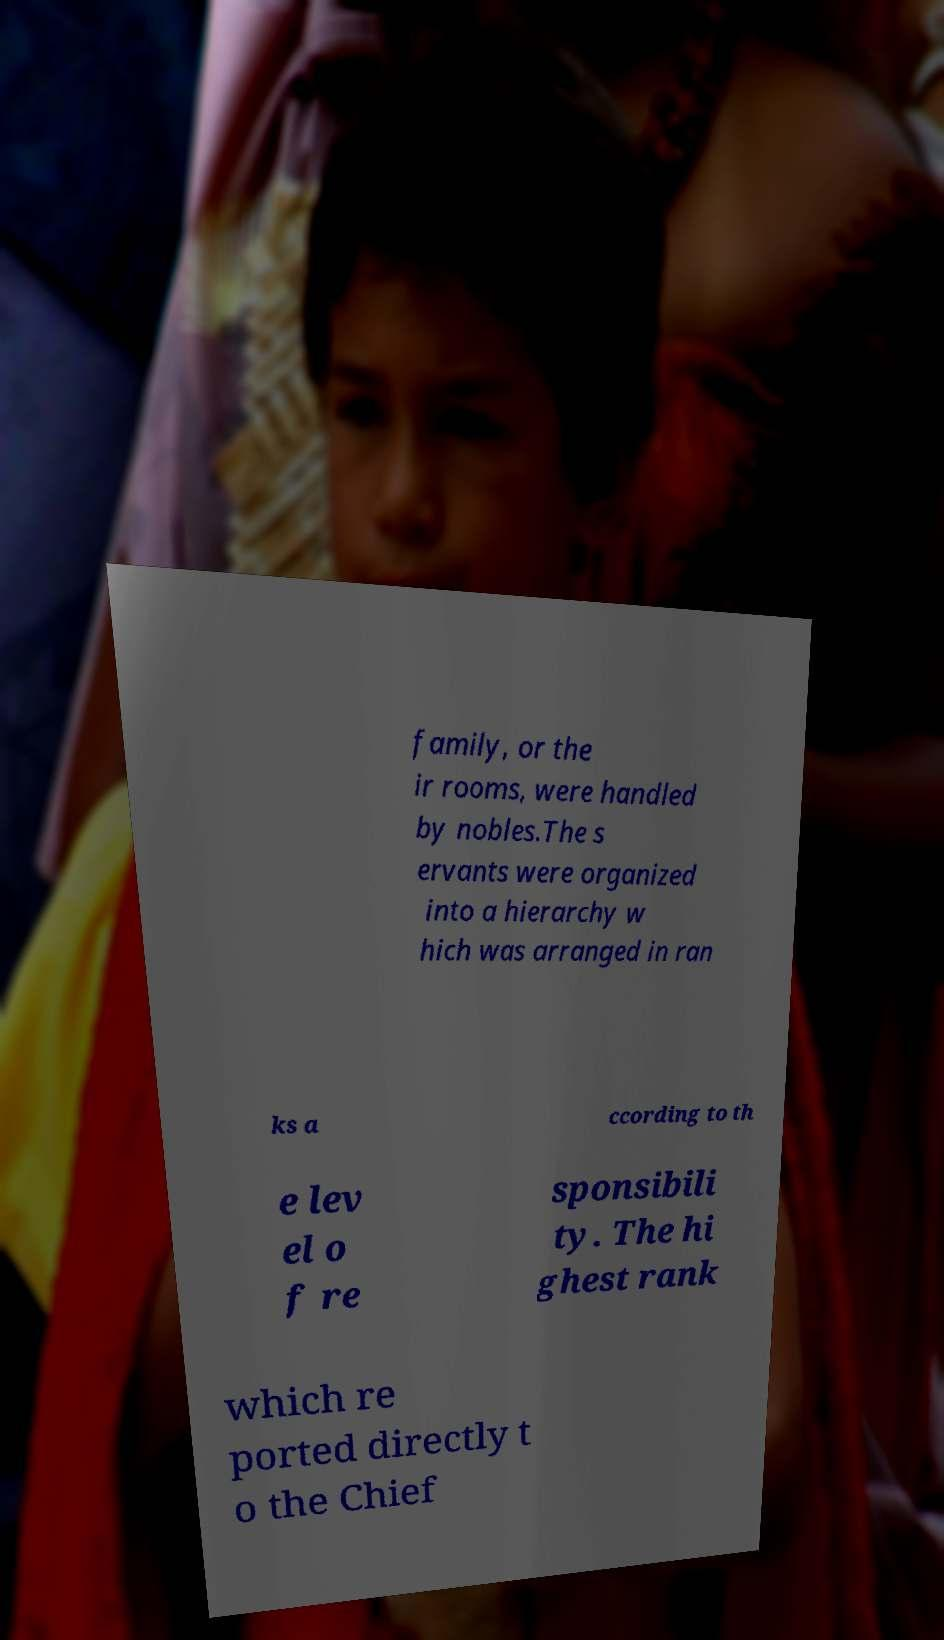Can you read and provide the text displayed in the image?This photo seems to have some interesting text. Can you extract and type it out for me? family, or the ir rooms, were handled by nobles.The s ervants were organized into a hierarchy w hich was arranged in ran ks a ccording to th e lev el o f re sponsibili ty. The hi ghest rank which re ported directly t o the Chief 